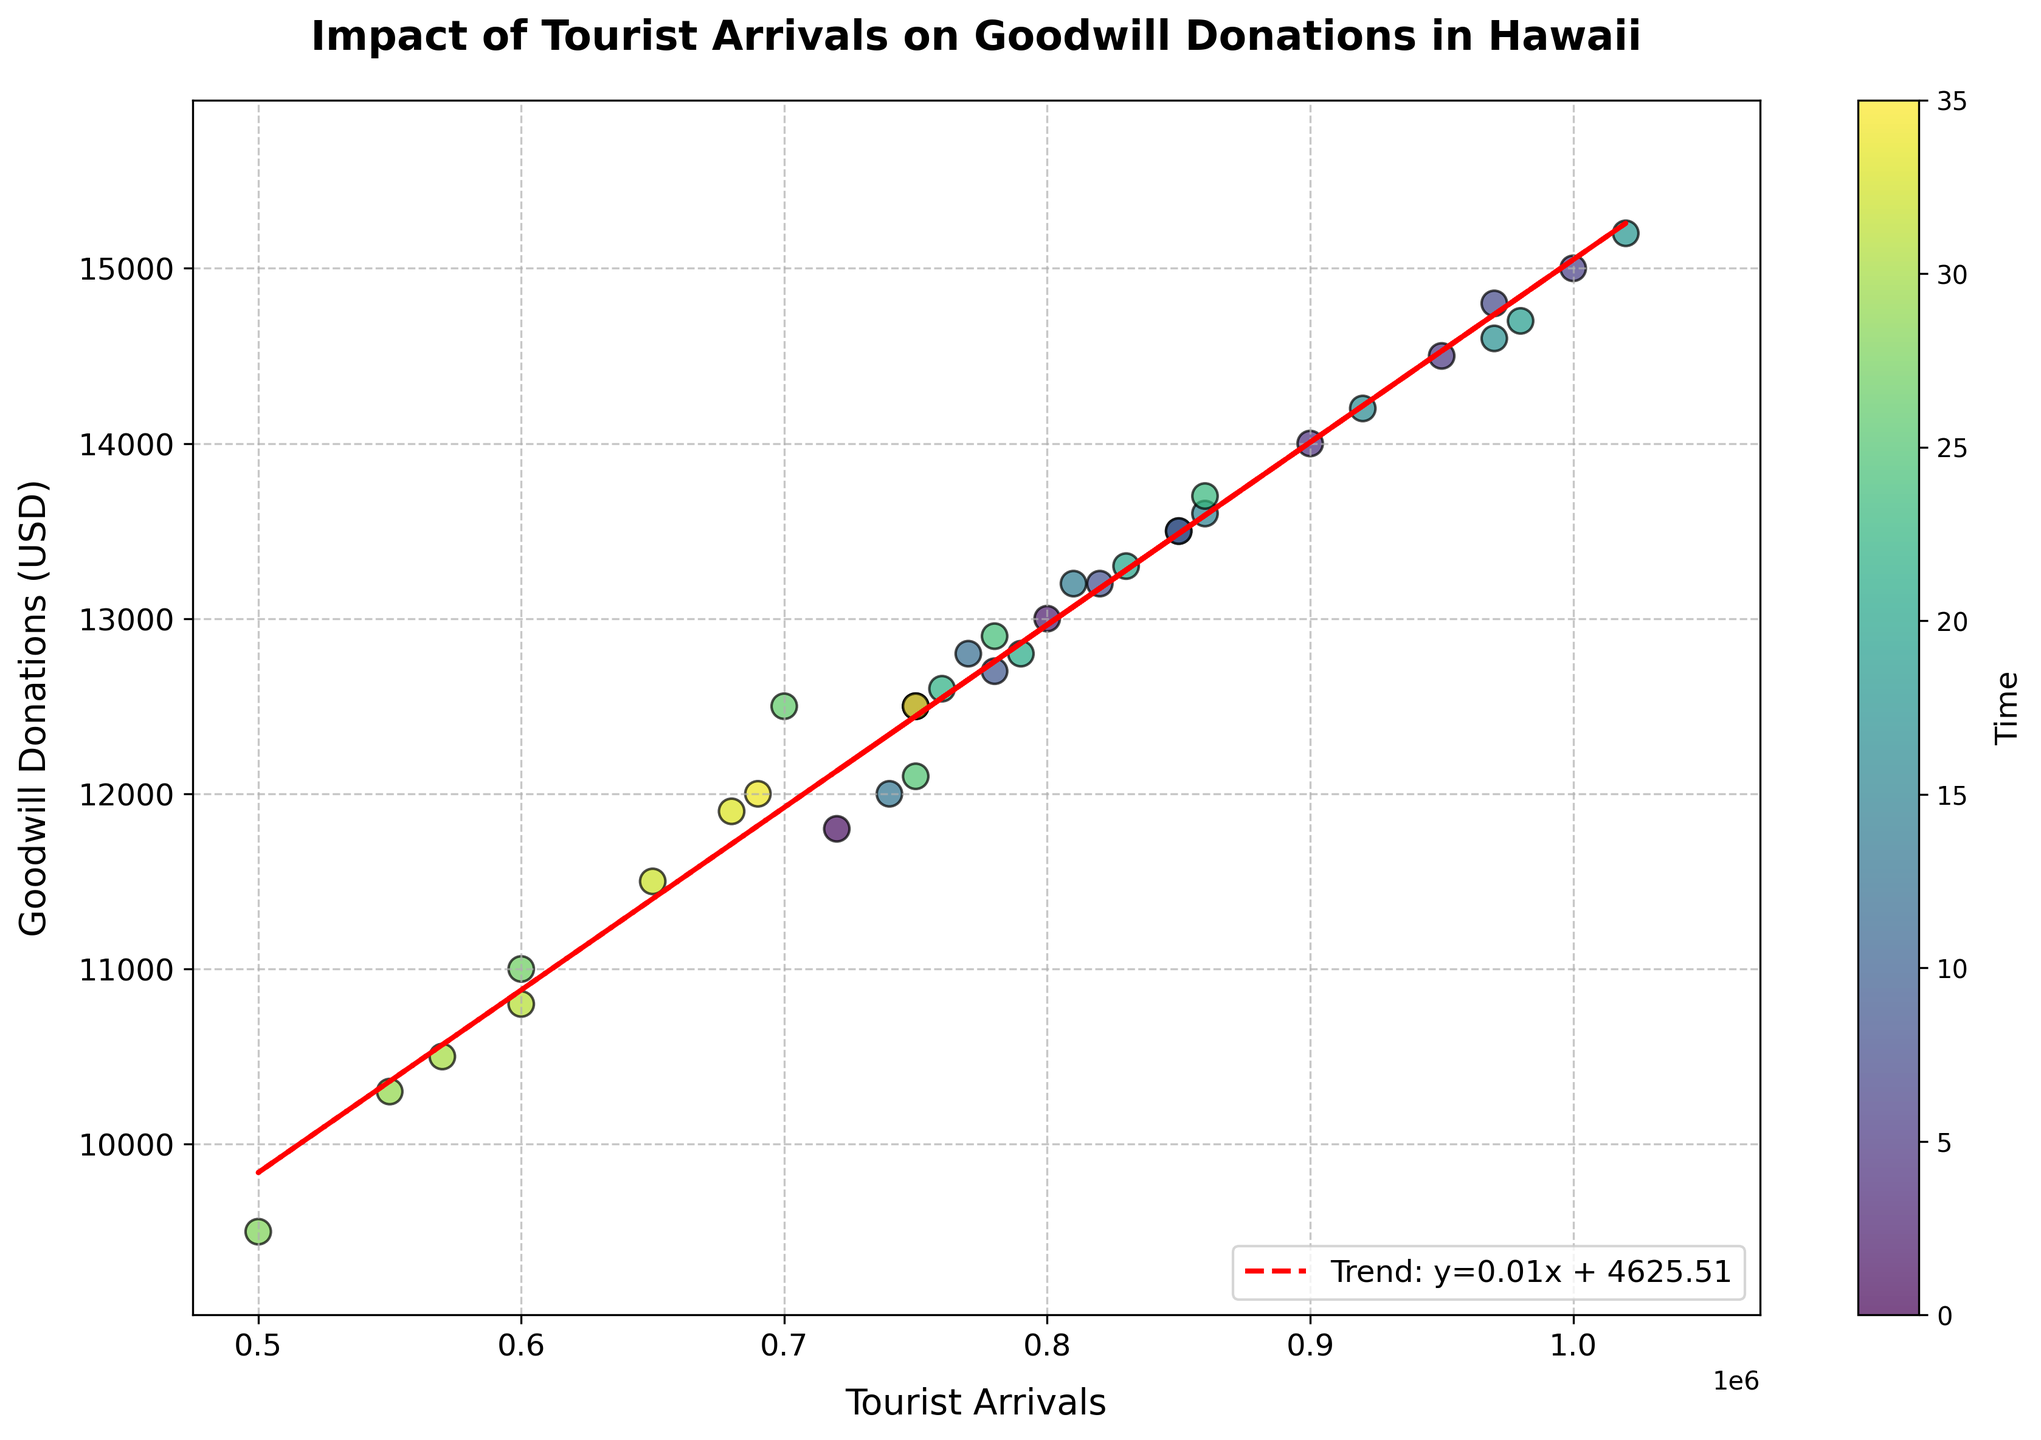What is the title of the figure? The title of the figure is written at the top and reads "Impact of Tourist Arrivals on Goodwill Donations in Hawaii".
Answer: Impact of Tourist Arrivals on Goodwill Donations in Hawaii What are the x-axis and y-axis labels? The x-axis label, found below the horizontal axis, is "Tourist Arrivals", and the y-axis label, found beside the vertical axis, is "Goodwill Donations (USD)".
Answer: Tourist Arrivals & Goodwill Donations (USD) How does the trend line described? The trend line is described in the legend as y=0.014x + 4950.00, indicating the linear relationship between tourist arrivals and donations.
Answer: y=0.014x + 4950.00 What is the value of Goodwill Donations when Tourist Arrivals are at 1000000? To find the value of Goodwill Donations when Tourist Arrivals are at 1000000, locate the point on the x-axis for 1000000. The corresponding point on the trend line is around y=19950.
Answer: 19950 What year appears to have the highest Goodwill Donations? By analyzing the scatter points, the highest Goodwill Donations appear around the year 2019 in July, where donations were around $15200.
Answer: 2019 Compare the Goodwill Donations in January 2018 and January 2020. Which one is higher, and by how much? Goodwill Donations in January 2018 were $12500 and in January 2020 were $12900. The difference is calculated as $12900 - $12500 = $400.
Answer: January 2020, $400 higher What is the general trend shown by the trend line? The trend line slopes upward, indicating a positive correlation between tourist arrivals and Goodwill donations. As tourist arrivals increase, donations tend to increase as well.
Answer: Positive correlation What are the minimum and maximum values of the Goodwill Donations presented in the data? The minimum value is seen around May 2020 with donations around $9500, and the maximum value is seen around July 2019 with donations around $15200.
Answer: $9500 & $15200 How do the donations in peak tourist seasons (June, July, August) compare to the rest of the year? The donations during peak tourist seasons (June, July, August) are generally higher compared to non-peak months, as indicated by the higher scatter points in those months.
Answer: Higher During which months did tourist arrivals dip significantly, and how did it affect Goodwill donations? Tourist arrivals dipped significantly around April to July 2020. This reduction corresponds with lower Goodwill donations as seen in the scatter plot, with April 2020 donations at around $11000.
Answer: April to July 2020 & Lower donations 